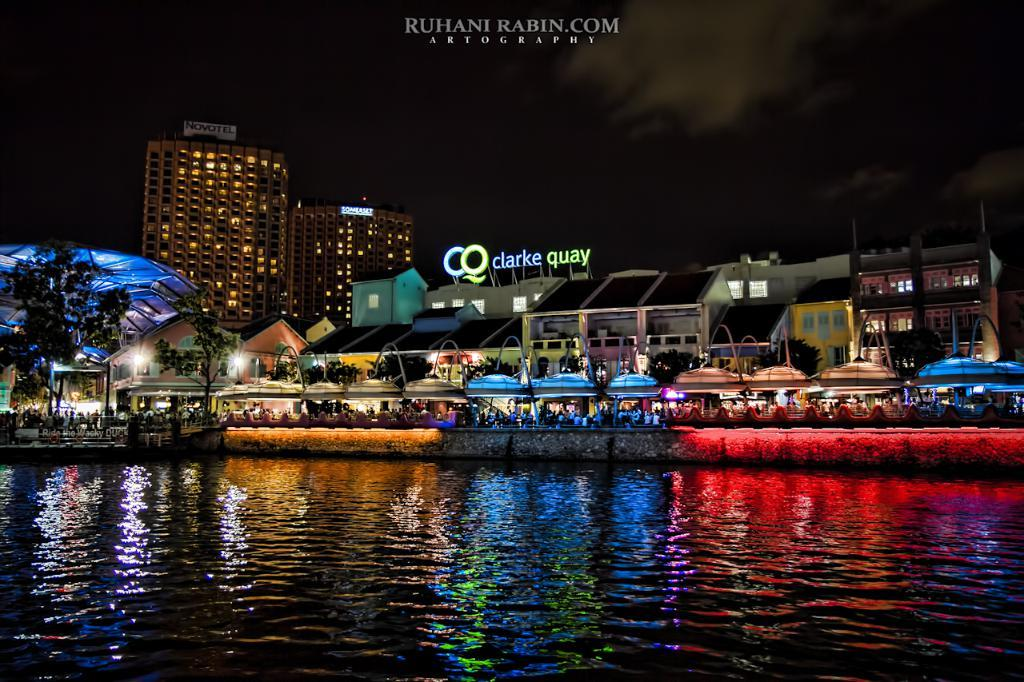What is visible at the bottom of the image? There are waves and water at the bottom of the image. What can be seen in the middle of the image? There are buildings, trees, people, tents, lights, and text in the middle of the image. What is visible at the top of the image? There are buildings, sky, clouds, and text at the top of the image. Can you see the earth in the image? The image does not show the earth; it only shows a portion of the scene, including waves, water, buildings, trees, people, tents, lights, text, sky, and clouds. What type of coat is the person wearing in the image? There are no people wearing coats in the image. 